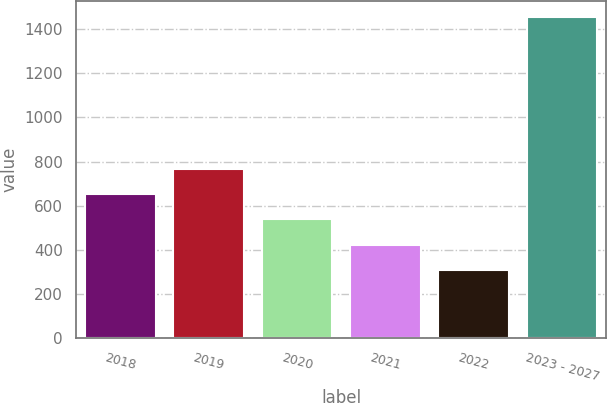<chart> <loc_0><loc_0><loc_500><loc_500><bar_chart><fcel>2018<fcel>2019<fcel>2020<fcel>2021<fcel>2022<fcel>2023 - 2027<nl><fcel>652.2<fcel>766.6<fcel>537.8<fcel>423.4<fcel>309<fcel>1453<nl></chart> 